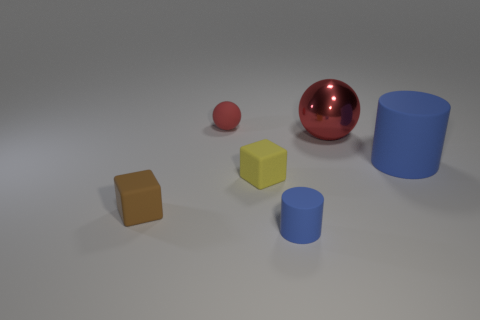The big blue thing that is the same material as the small ball is what shape?
Give a very brief answer. Cylinder. Is there any other thing that has the same shape as the small red object?
Your response must be concise. Yes. What number of large blue cylinders are left of the large matte cylinder?
Your response must be concise. 0. Is the number of small cylinders that are on the right side of the small yellow matte cube the same as the number of blue cylinders?
Your answer should be very brief. No. Does the small ball have the same material as the tiny brown thing?
Your answer should be very brief. Yes. How big is the rubber thing that is both left of the yellow matte block and in front of the large red shiny object?
Make the answer very short. Small. What number of red metallic objects have the same size as the brown object?
Ensure brevity in your answer.  0. Is the number of brown matte things the same as the number of blocks?
Your answer should be very brief. No. What is the size of the sphere in front of the object behind the big red metal object?
Your answer should be very brief. Large. There is a small thing in front of the tiny brown cube; is it the same shape as the tiny red object behind the brown matte thing?
Give a very brief answer. No. 